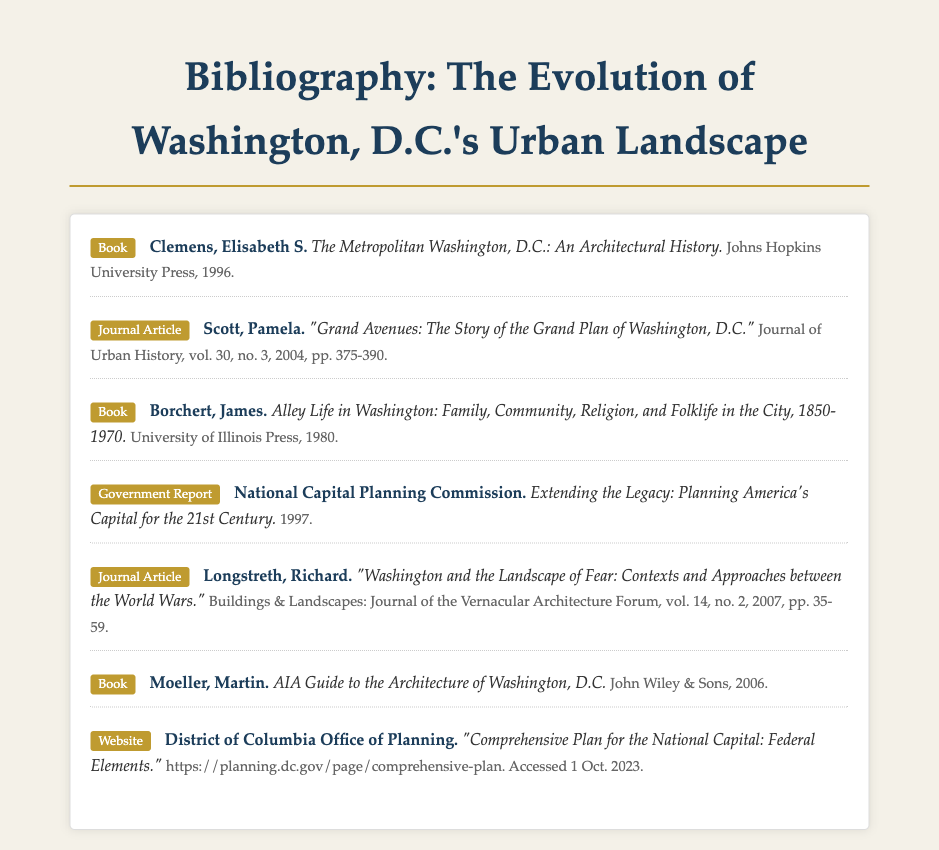What is the title of the first entry? The title of the first entry can be found in the document structure which includes the author, title, and publication details.
Answer: The Metropolitan Washington, D.C.: An Architectural History Who authored "Grand Avenues: The Story of the Grand Plan of Washington, D.C."? The author's name is listed alongside the title and metadata within the journal article entry.
Answer: Pamela Scott In what year was "Alley Life in Washington" published? The publication year can be found within the bibliographic entry for the book, denoting when it was released.
Answer: 1980 What type of document is "Extending the Legacy: Planning America's Capital for the 21st Century"? The type can be identified at the beginning of the entry denoting the nature of the source.
Answer: Government Report How many authors are listed in the bibliography? Counting the unique authors from the entries provides the total number of authors represented.
Answer: 6 What organization published the "Comprehensive Plan for the National Capital"? The organization responsible for the publication is indicated clearly in the website entry metadata.
Answer: District of Columbia Office of Planning Which book was published by Johns Hopkins University Press? The publication details of the book will reveal the publisher when examining the bibliographic entries.
Answer: The Metropolitan Washington, D.C.: An Architectural History What volume and number is the journal article "Washington and the Landscape of Fear" published in? This information is found in the metadata of the corresponding journal article entry.
Answer: vol. 14, no. 2 